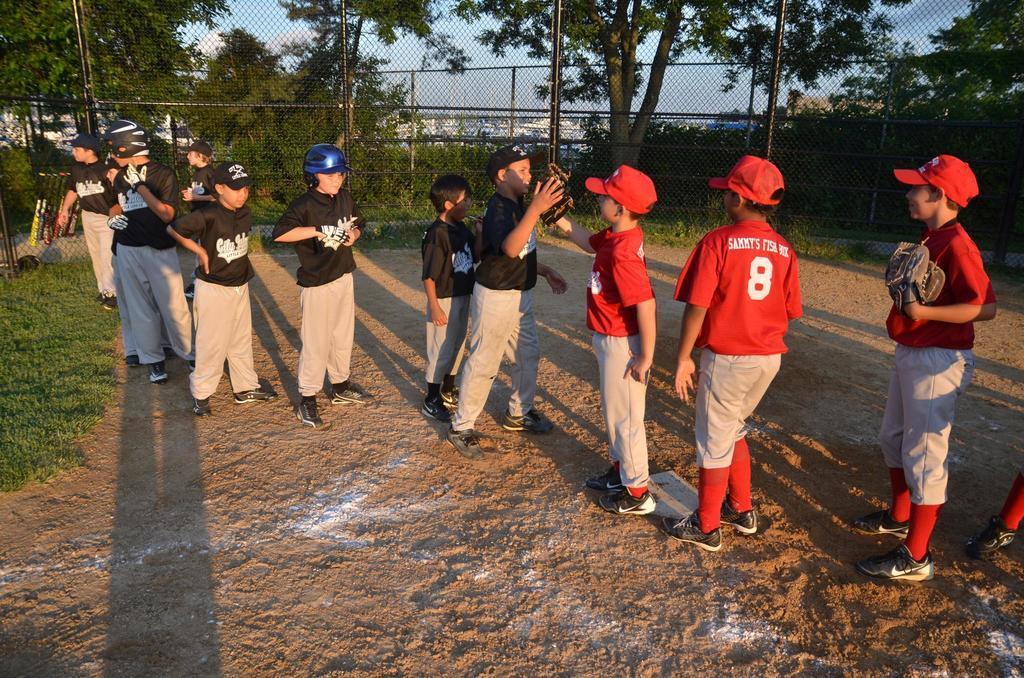Could you give a brief overview of what you see in this image? In this picture we can see a group of people standing on the ground and in the background we can see the grass, fences, trees, bats, some objects and the sky. 